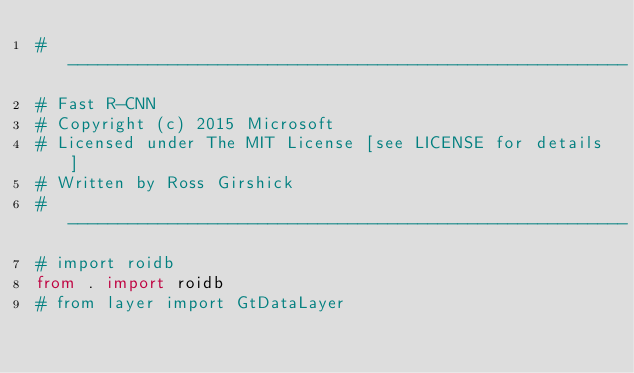<code> <loc_0><loc_0><loc_500><loc_500><_Python_># --------------------------------------------------------
# Fast R-CNN
# Copyright (c) 2015 Microsoft
# Licensed under The MIT License [see LICENSE for details]
# Written by Ross Girshick
# --------------------------------------------------------
# import roidb
from . import roidb
# from layer import GtDataLayer</code> 